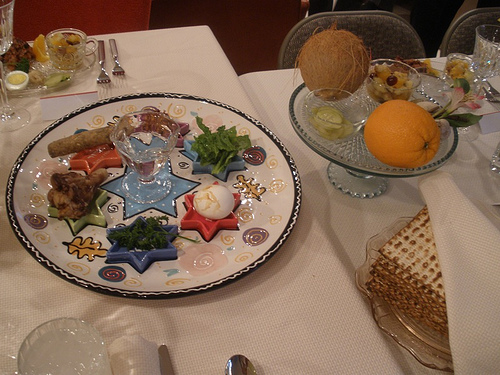Please provide the bounding box coordinate of the region this sentence describes: a clear glass cake plate. The bounding box coordinates for the region describing a clear glass cake plate are approximately [0.57, 0.29, 0.92, 0.52]. 